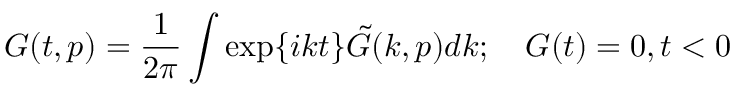Convert formula to latex. <formula><loc_0><loc_0><loc_500><loc_500>G ( t , p ) = \frac { 1 } { 2 \pi } \int \exp \{ i k t \} \tilde { G } ( k , p ) d k ; \quad G ( t ) = 0 , t < 0</formula> 